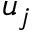Convert formula to latex. <formula><loc_0><loc_0><loc_500><loc_500>u _ { j }</formula> 